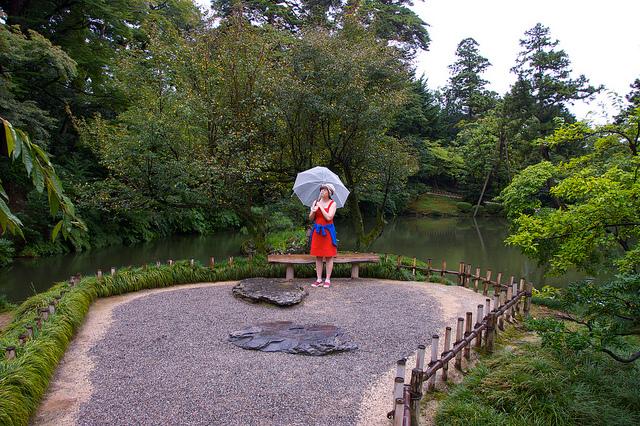What color is the woman's shoes?
Quick response, please. Red. Could a cruise ship traverse this waterway?
Give a very brief answer. No. What is the waterway for?
Keep it brief. Travel. 